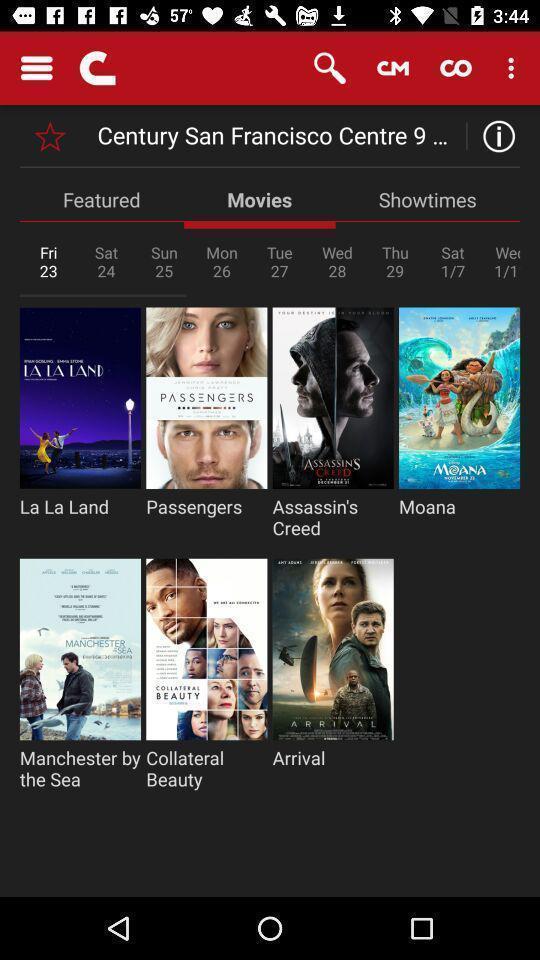Give me a summary of this screen capture. Page showing variety of movies. 